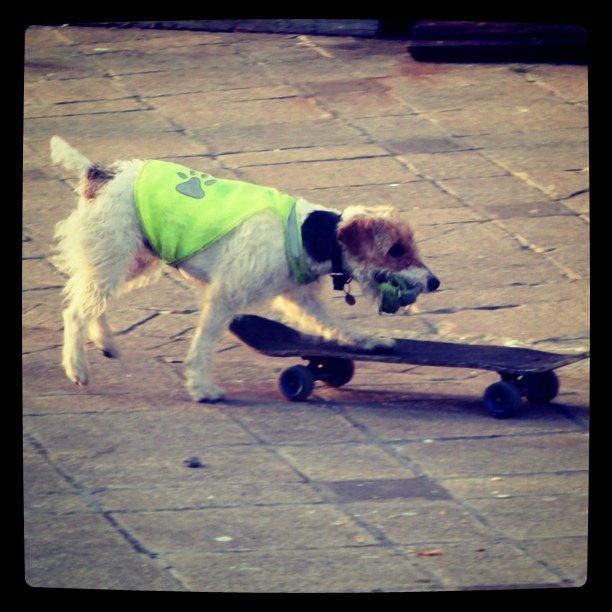Is it easy to teach a dog to skateboard?
Quick response, please. No. What is the dog wearing?
Write a very short answer. Vest. Where is the dog playing with the skateboard?
Be succinct. Sidewalk. Does the dog have something in his mouth?
Answer briefly. Yes. 